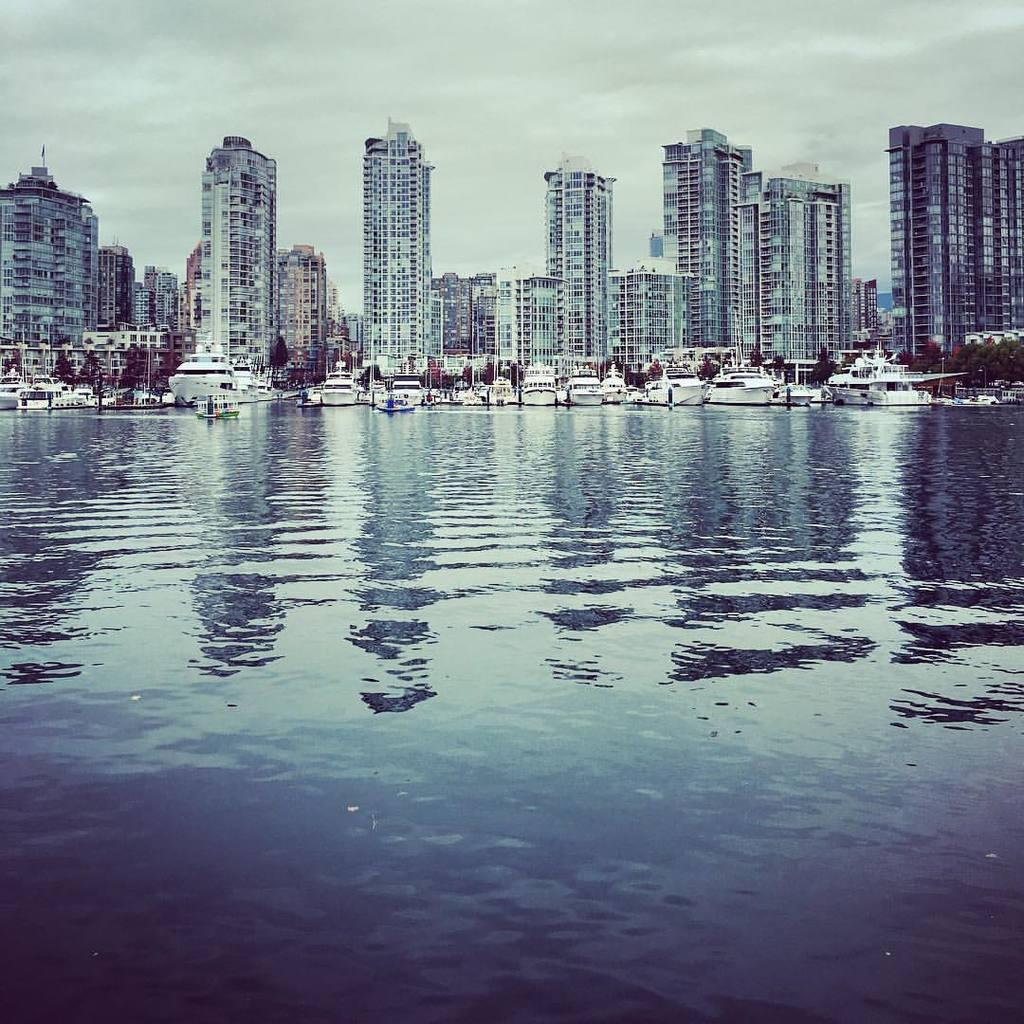What is visible in the image? Water is visible in the image. What can be seen in the background of the image? In the background of the image, there are ships, buildings, and clouds in the sky. How many cherries are floating on the water in the image? There are no cherries visible in the image; only water, ships, buildings, and clouds are present. 